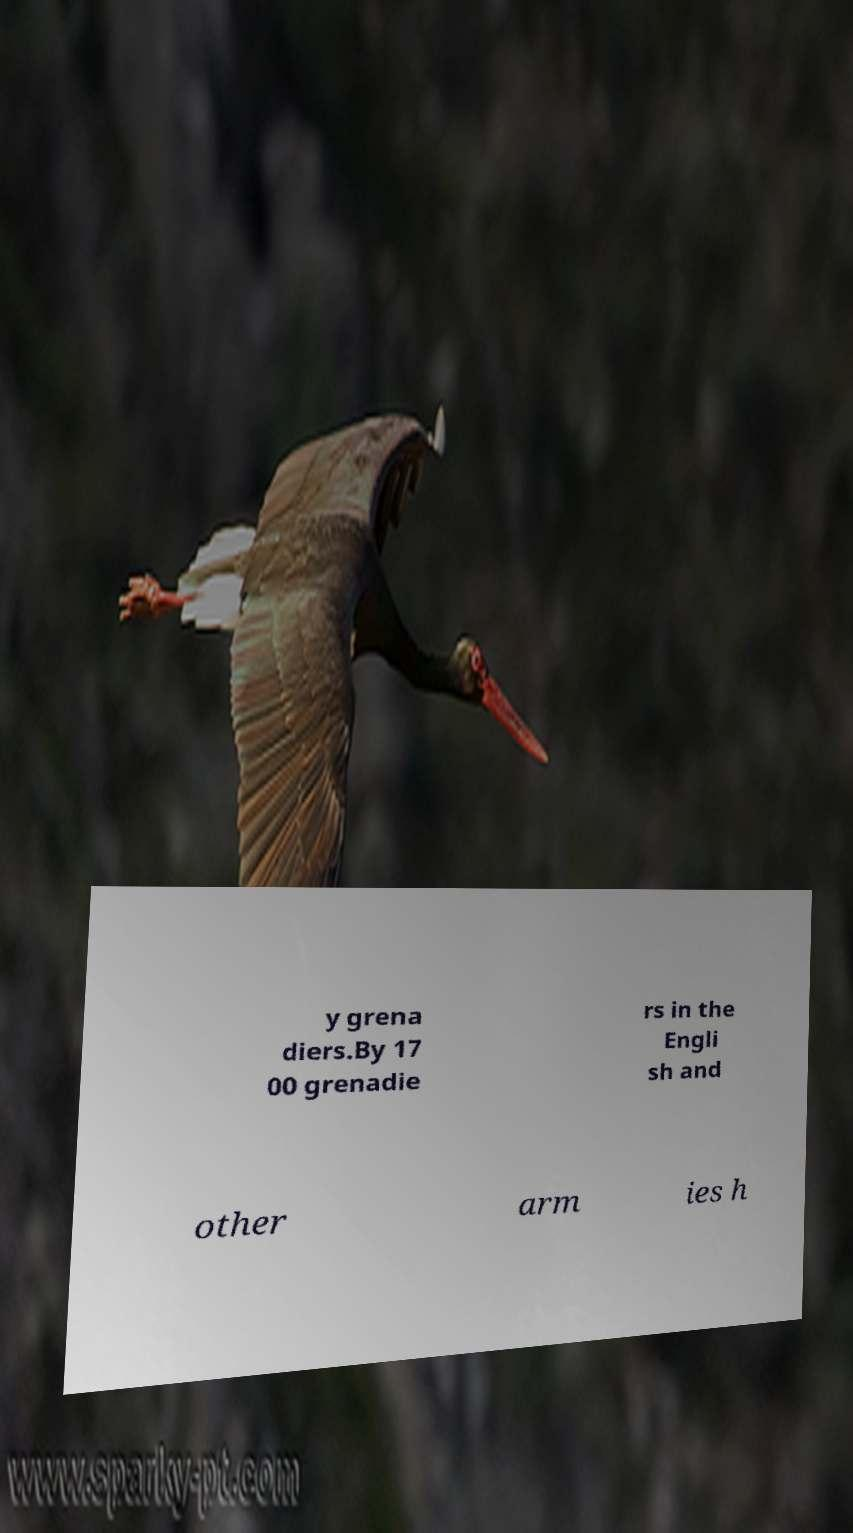What messages or text are displayed in this image? I need them in a readable, typed format. y grena diers.By 17 00 grenadie rs in the Engli sh and other arm ies h 